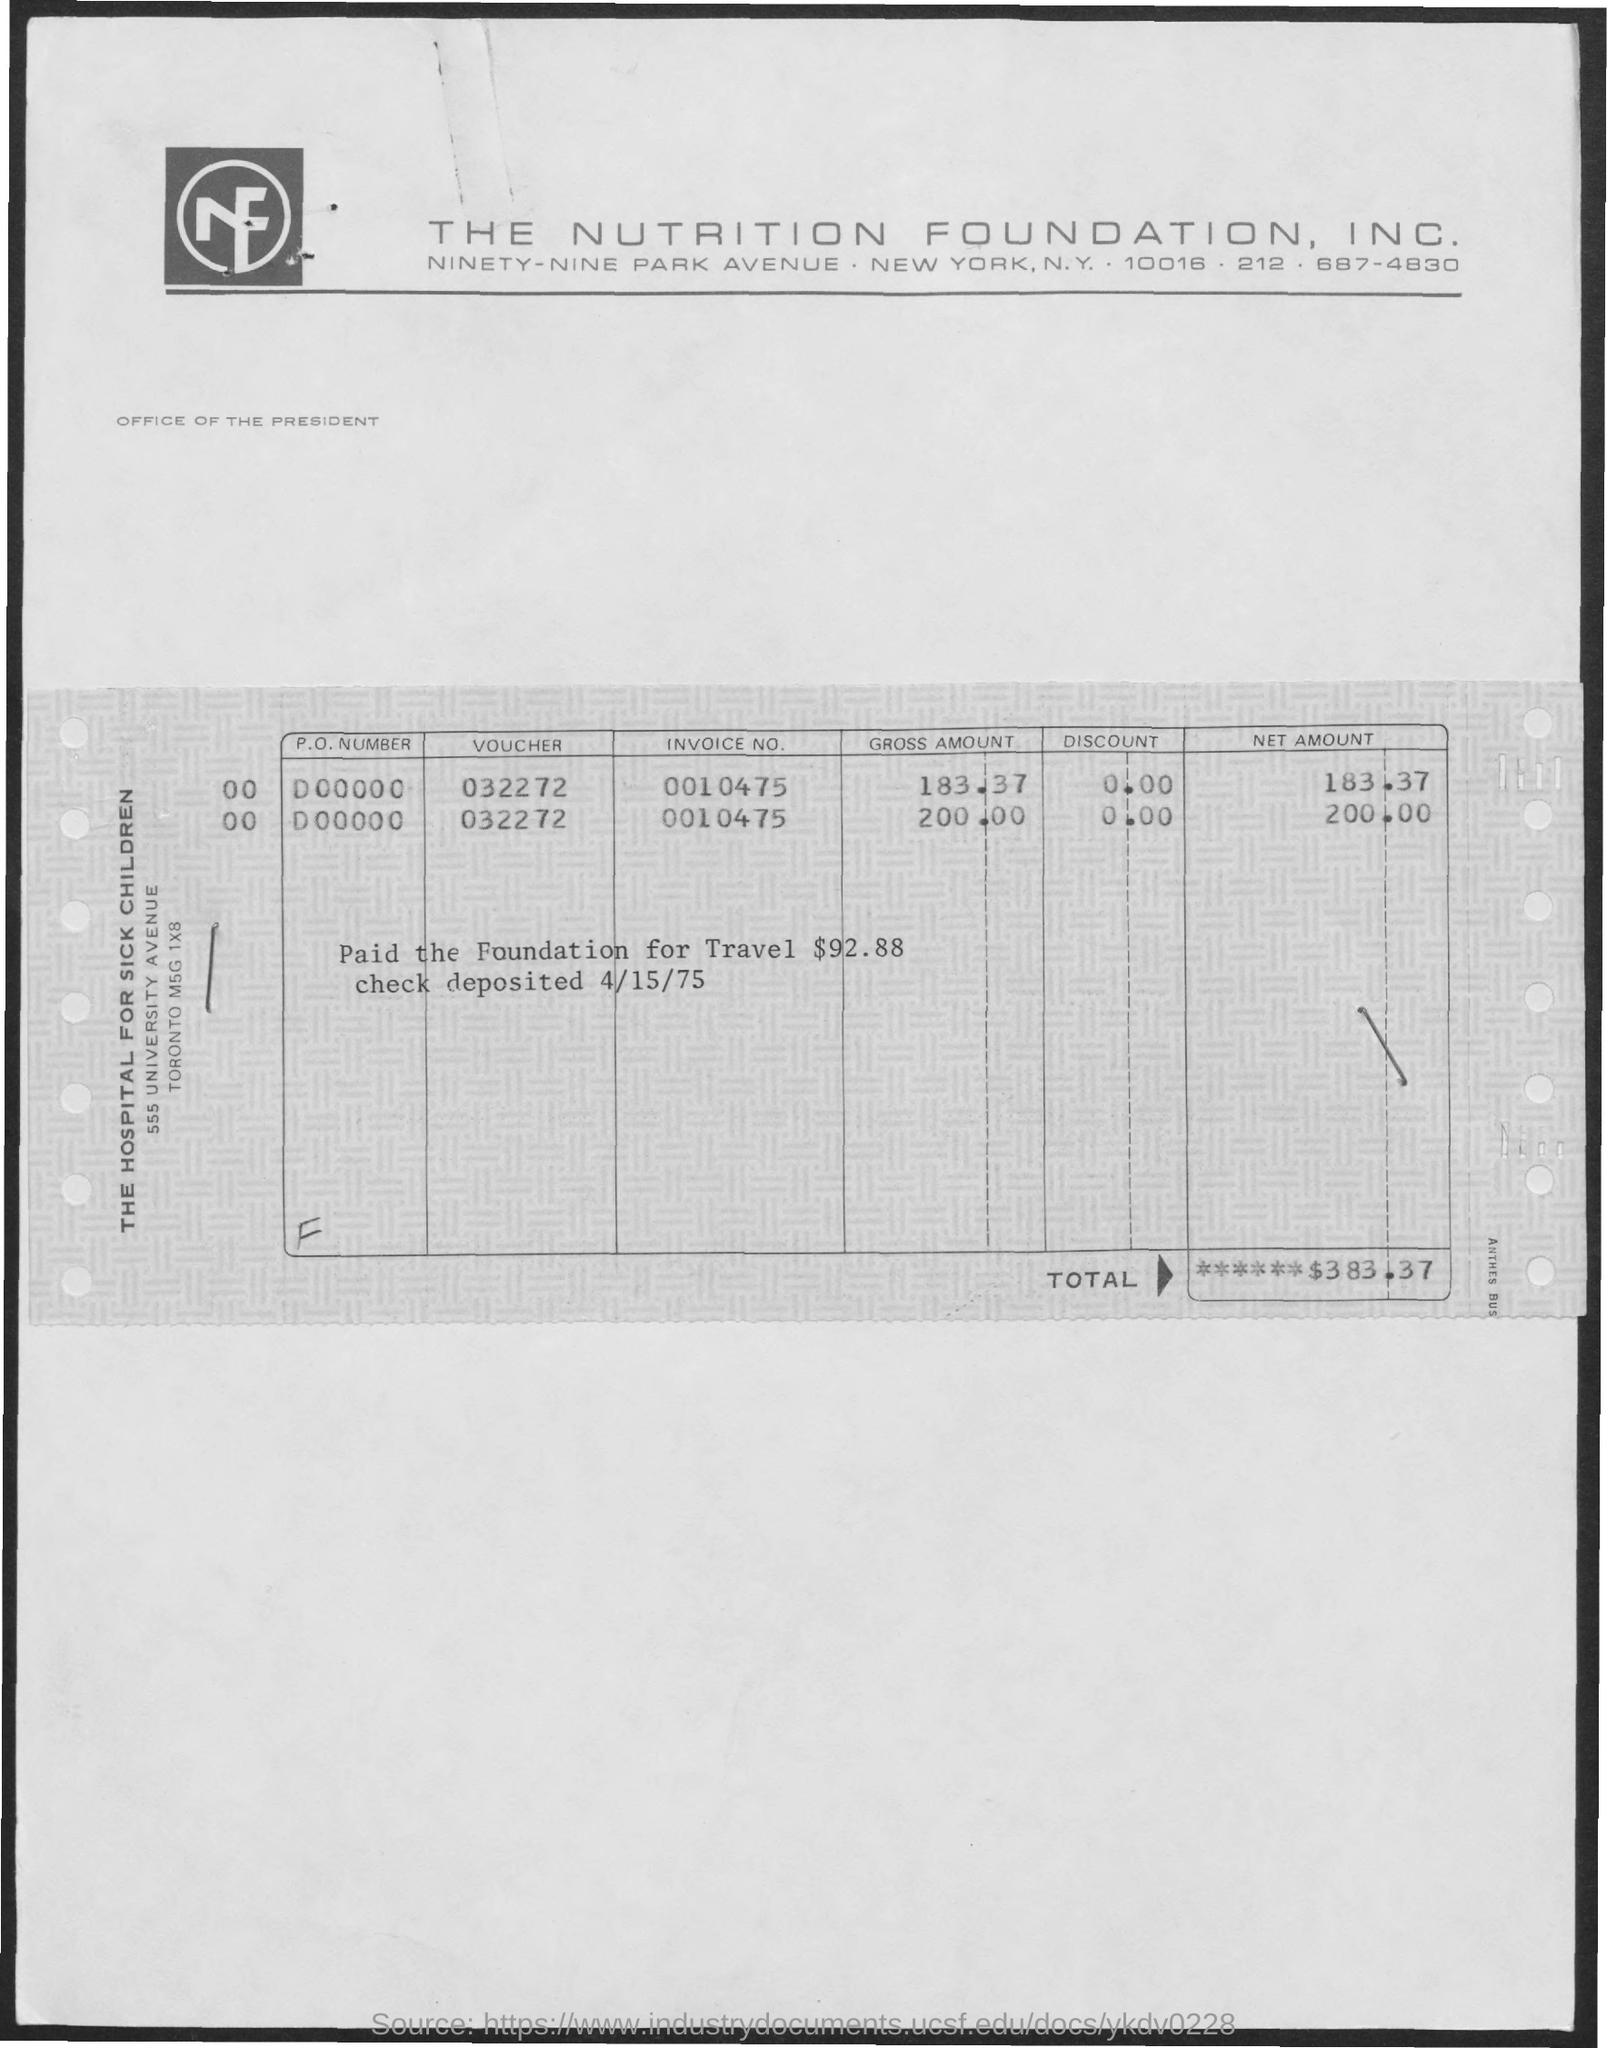Point out several critical features in this image. The foundation was paid a total of $92.88 for travel expenses. The telephone number of Nutrition Foundation, Inc. is 212 687-4830. The total amount is $383.37. 